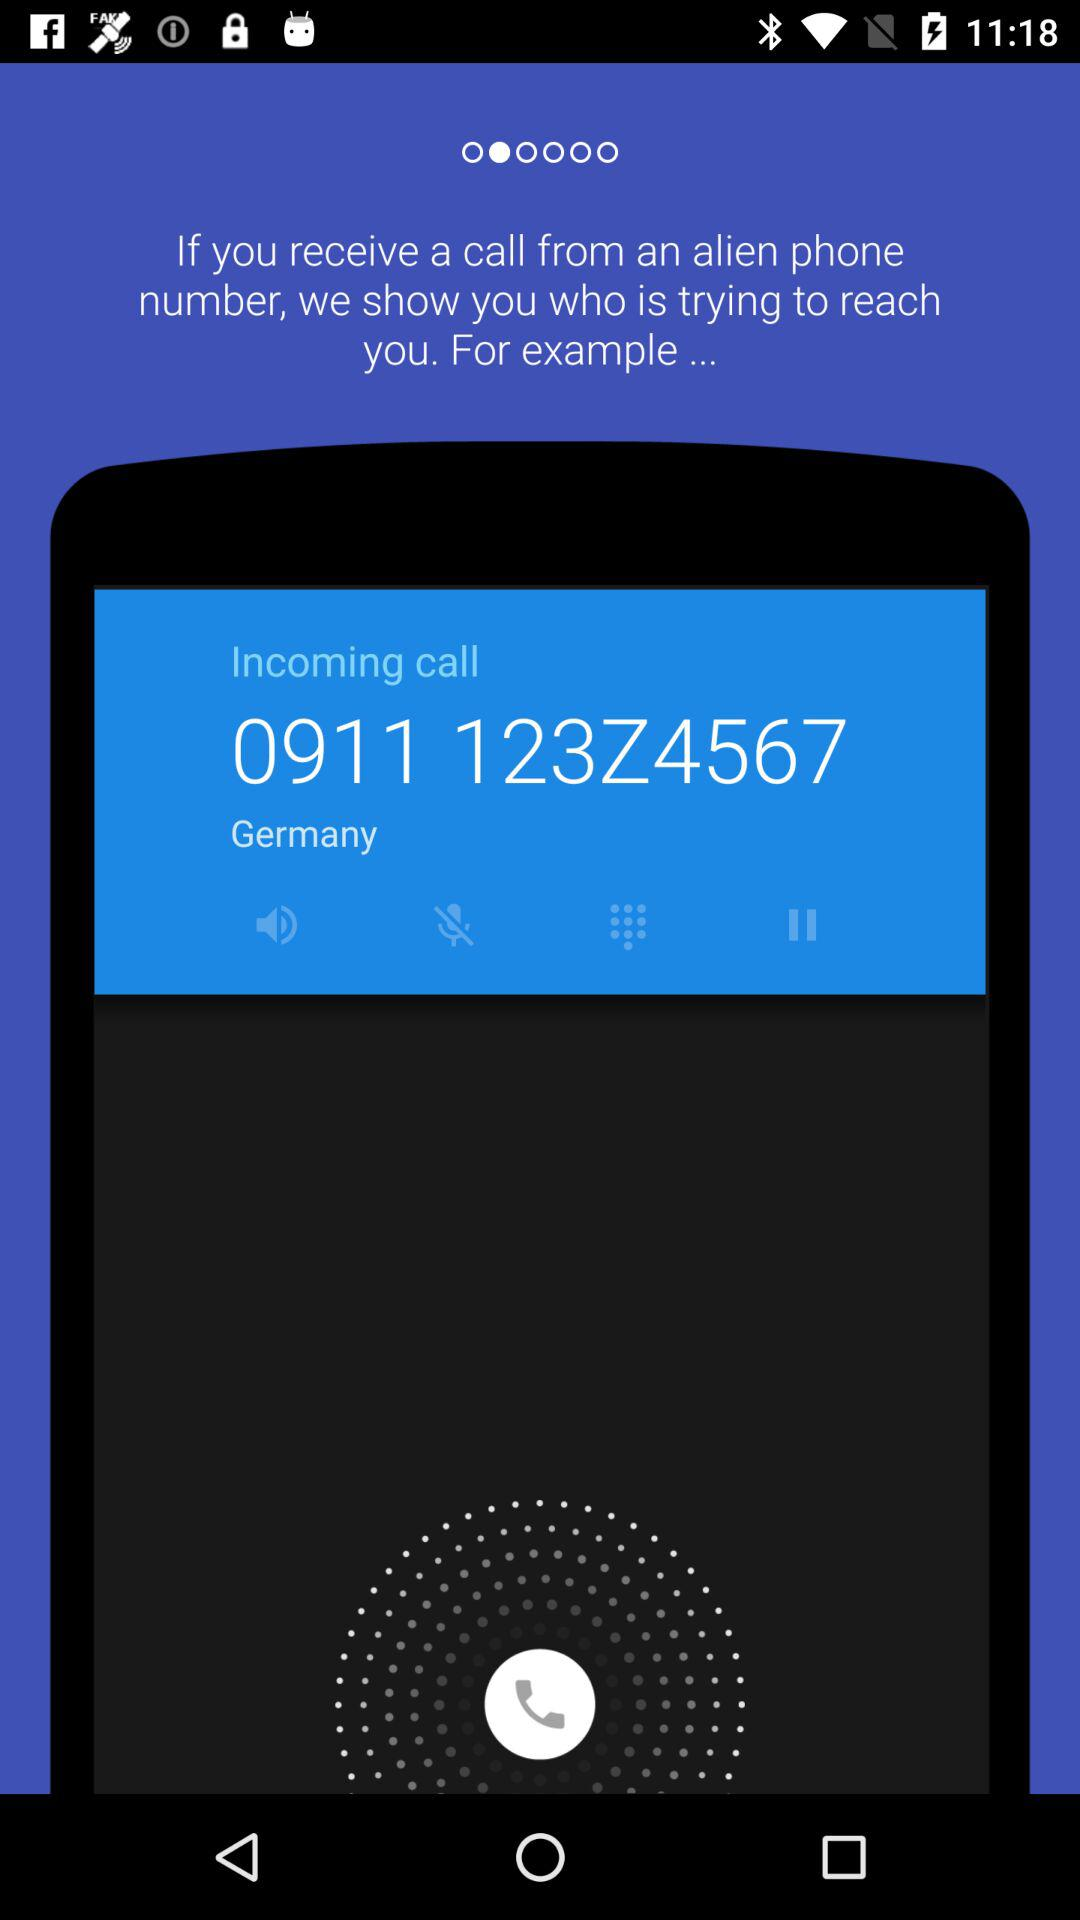What is the phone number? The phone number is 0911 123Z4567. 